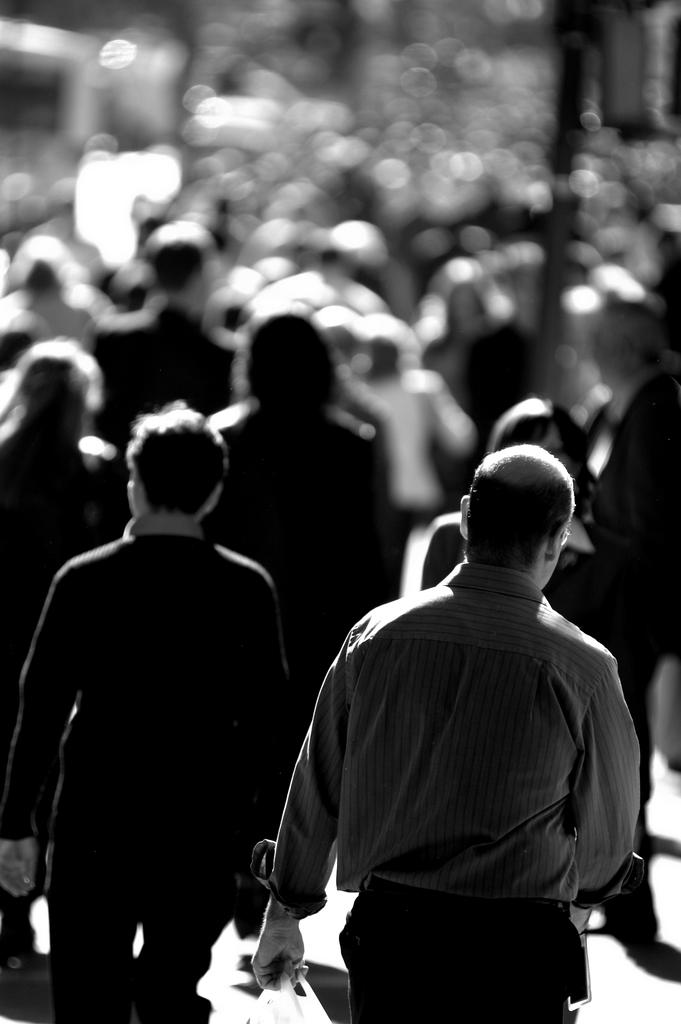What is happening in the image? There is a group of people in the image, and they are walking. What can be observed about the image's color scheme? The image is in black and white color. What is the value of the boundary in the image? There is no mention of a boundary in the image, so it is not possible to determine its value. 